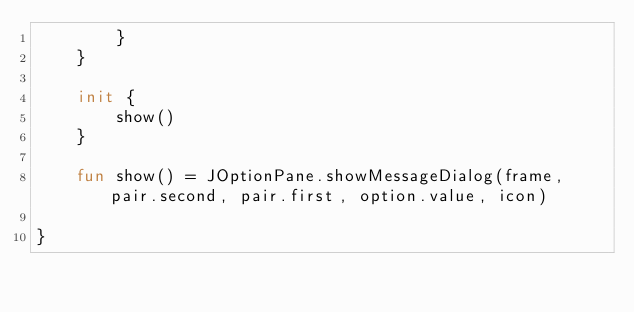<code> <loc_0><loc_0><loc_500><loc_500><_Kotlin_>        }
    }

    init {
        show()
    }

    fun show() = JOptionPane.showMessageDialog(frame, pair.second, pair.first, option.value, icon)

}</code> 